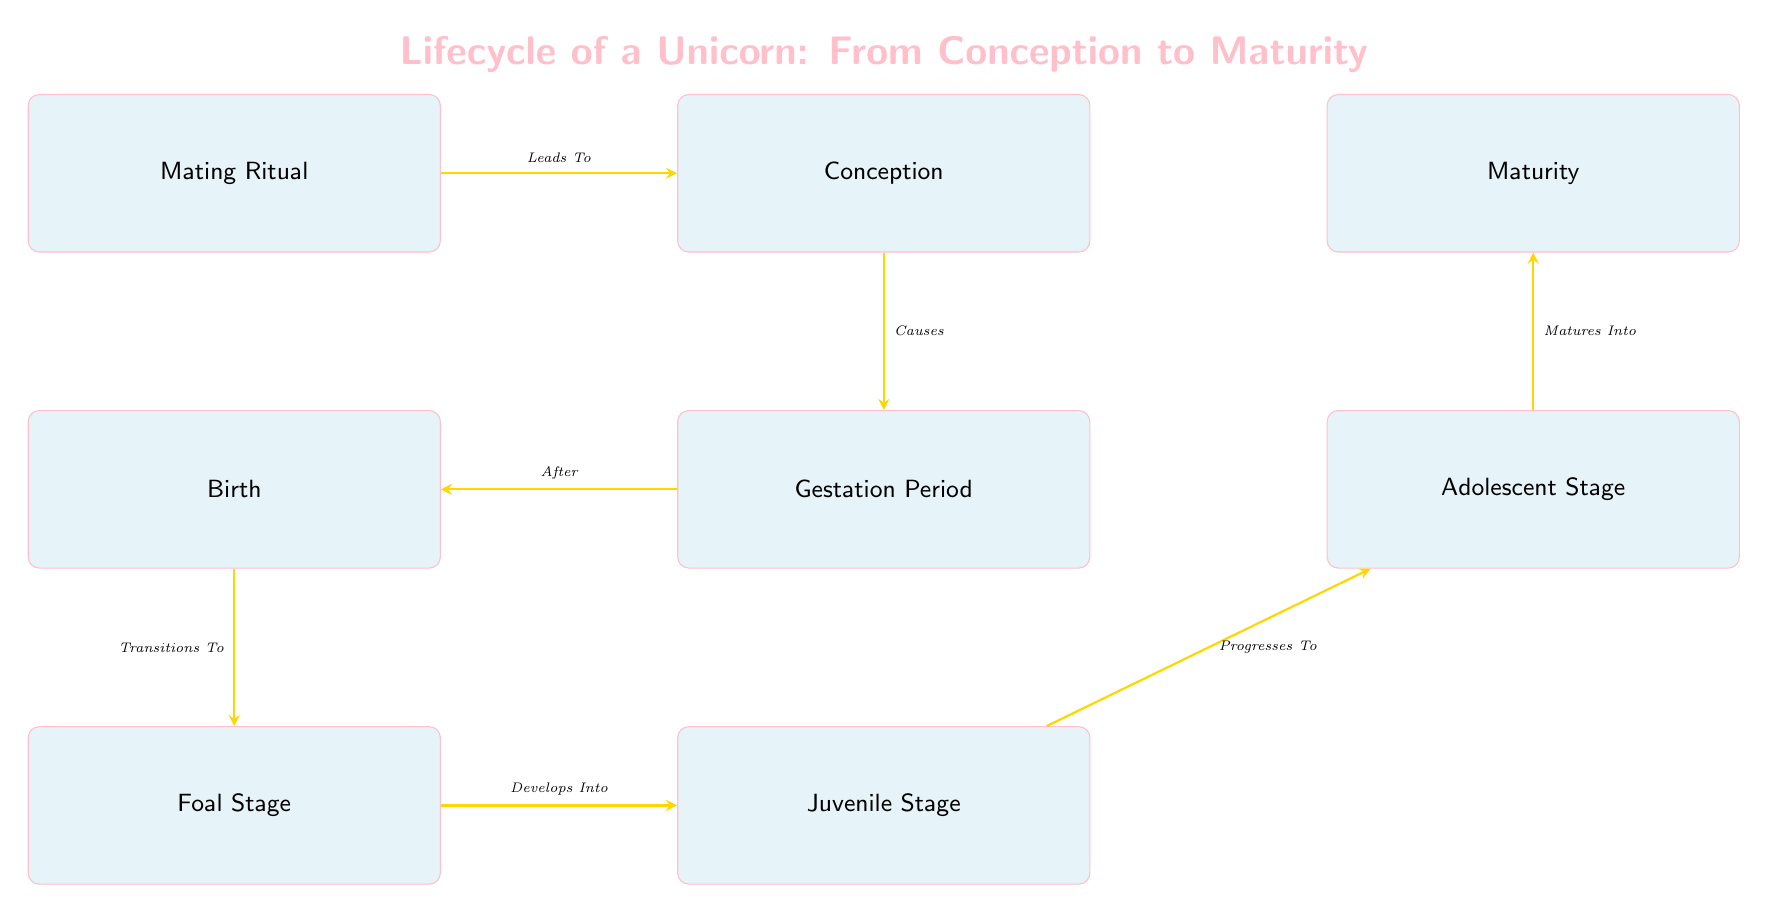What is the first step in the unicorn lifecycle? The first step is the "Mating Ritual," as indicated at the top of the flow chart.
Answer: Mating Ritual How long is the gestation period for a unicorn? The diagram specifies that the gestation period lasts approximately "10 months."
Answer: 10 months What does a newborn unicorn transition to? According to the flow chart, a newborn unicorn transitions to the "Foal Stage" after birth.
Answer: Foal Stage After the juvenile stage, which stage does the unicorn progress to? The diagram shows an arrow from the "Juvenile Stage" pointing to the "Adolescent Stage," indicating this progression.
Answer: Adolescent Stage What is the age at which a unicorn reaches maturity? The chart indicates that a unicorn reaches maturity at "8+" years of age.
Answer: 8+ How many total stages are there in the lifecycle of a unicorn? The chart lists a total of 8 distinct stages, starting from "Mating Ritual" to "Maturity."
Answer: 8 What happens directly after the gestation period? The diagram shows that after the "Gestation Period," the next event is "Birth."
Answer: Birth Which stage involves the development of the primary horn? The "Juvenile Stage," as indicated in the flow chart, is where the primary horn develops.
Answer: Juvenile Stage What denotes the transition from the foal stage to the next stage? The transition is indicated by the label "Develops Into" leading from "Foal Stage" to "Juvenile Stage."
Answer: Develops Into 